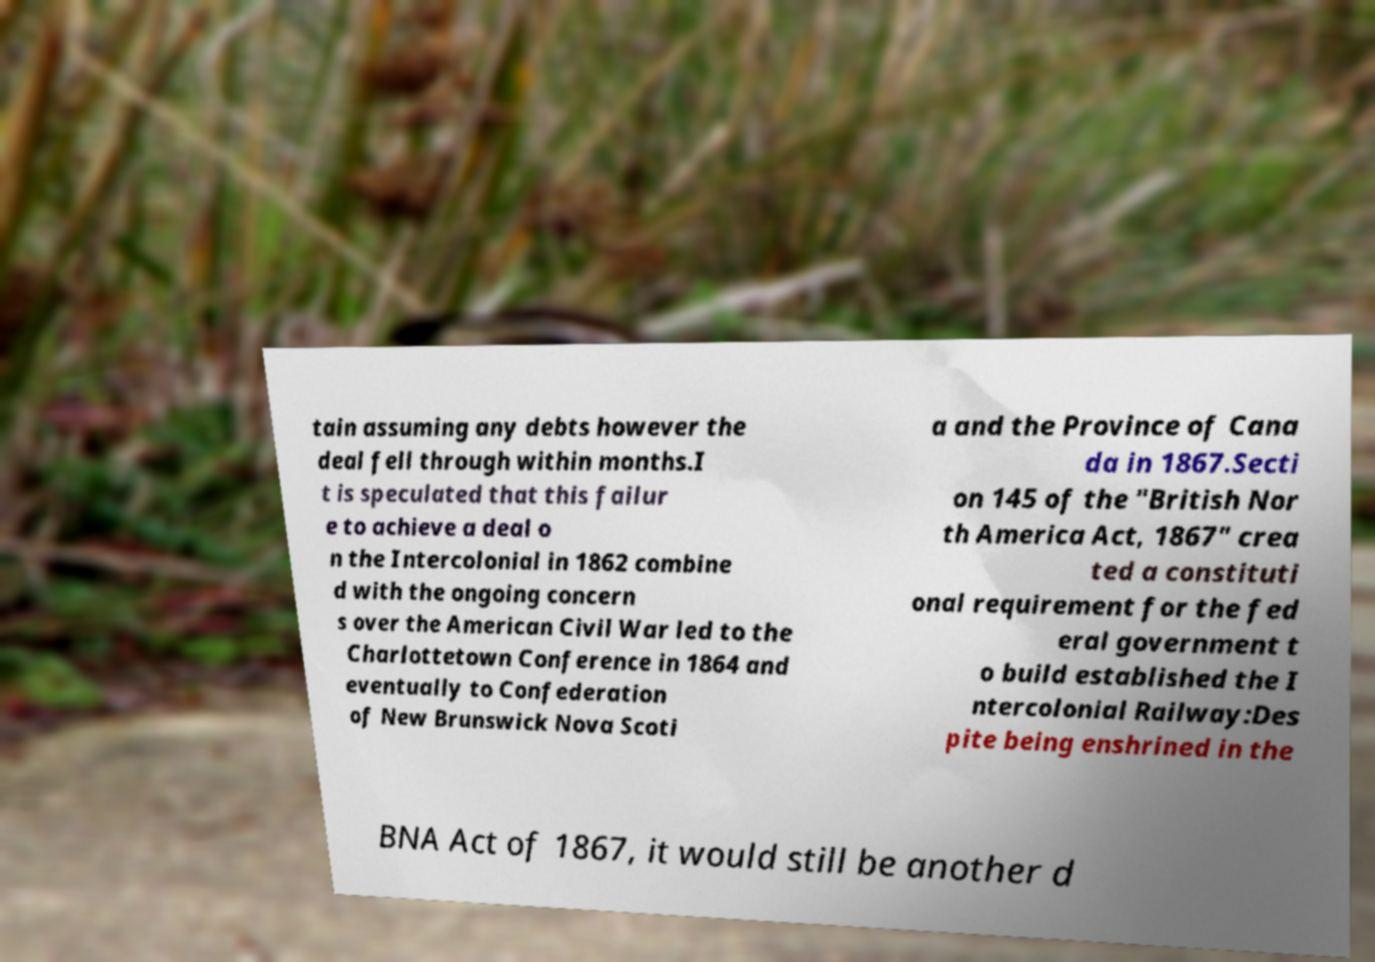Could you extract and type out the text from this image? tain assuming any debts however the deal fell through within months.I t is speculated that this failur e to achieve a deal o n the Intercolonial in 1862 combine d with the ongoing concern s over the American Civil War led to the Charlottetown Conference in 1864 and eventually to Confederation of New Brunswick Nova Scoti a and the Province of Cana da in 1867.Secti on 145 of the "British Nor th America Act, 1867" crea ted a constituti onal requirement for the fed eral government t o build established the I ntercolonial Railway:Des pite being enshrined in the BNA Act of 1867, it would still be another d 